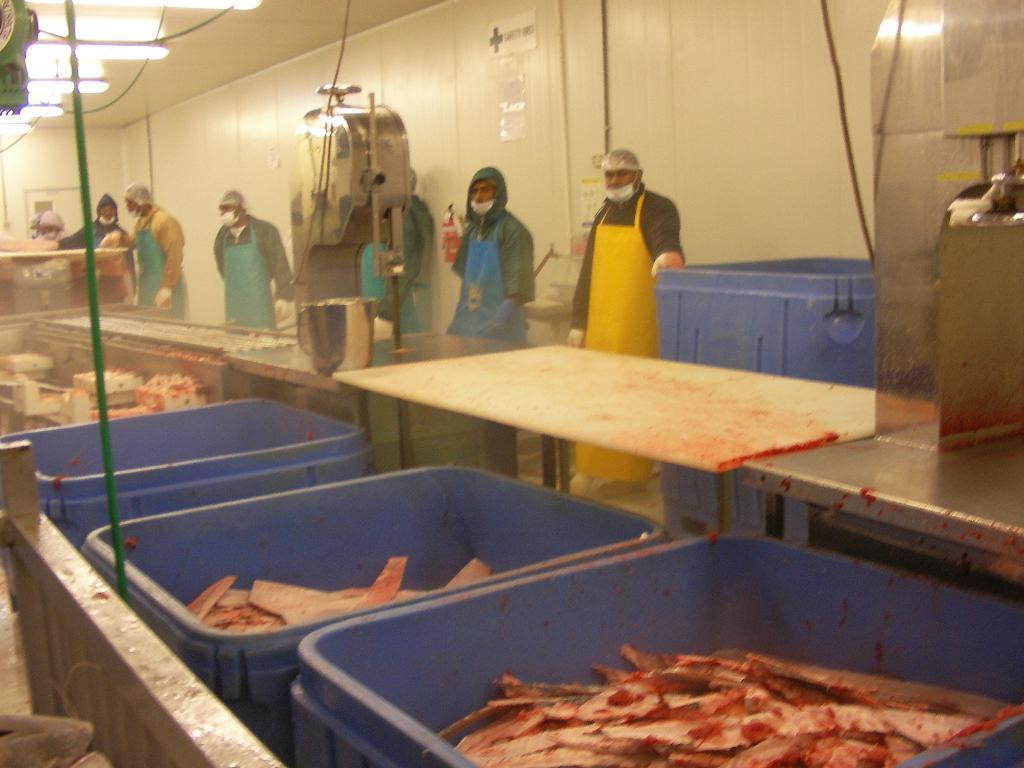Could you give a brief overview of what you see in this image? In the foreground of this image, there are few objects in the blue color baskets. On the left, there is a railing. In the middle, there are machinery and the tables. Behind it, there are people standing wearing aprons and masks and we can also see the wall and few lights to the ceiling. 